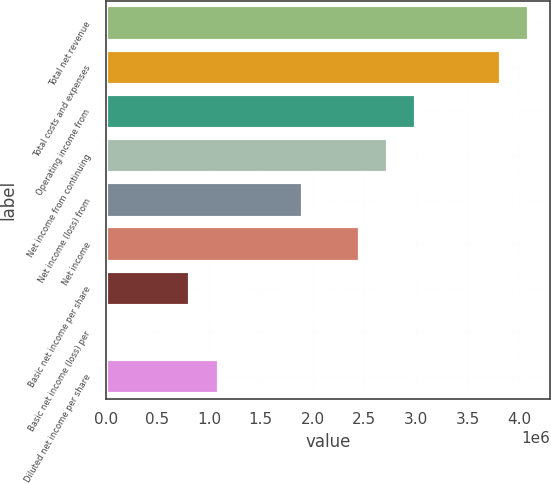<chart> <loc_0><loc_0><loc_500><loc_500><bar_chart><fcel>Total net revenue<fcel>Total costs and expenses<fcel>Operating income from<fcel>Net income from continuing<fcel>Net income (loss) from<fcel>Net income<fcel>Basic net income per share<fcel>Basic net income (loss) per<fcel>Diluted net income per share<nl><fcel>4.09611e+06<fcel>3.82304e+06<fcel>3.00382e+06<fcel>2.73074e+06<fcel>1.91152e+06<fcel>2.45767e+06<fcel>819222<fcel>0.02<fcel>1.0923e+06<nl></chart> 